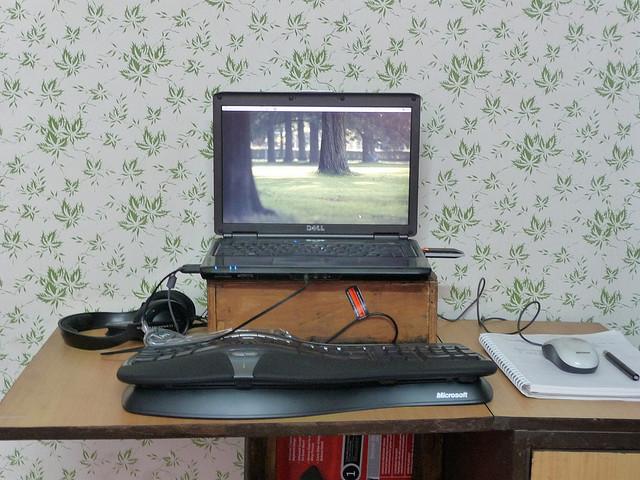What setting is shown on the screen of the laptop?
Short answer required. Park. Who made the keyboard?
Give a very brief answer. Microsoft. How many time-telling devices are on this desk?
Write a very short answer. 1. Is this a desktop computer?
Give a very brief answer. No. 